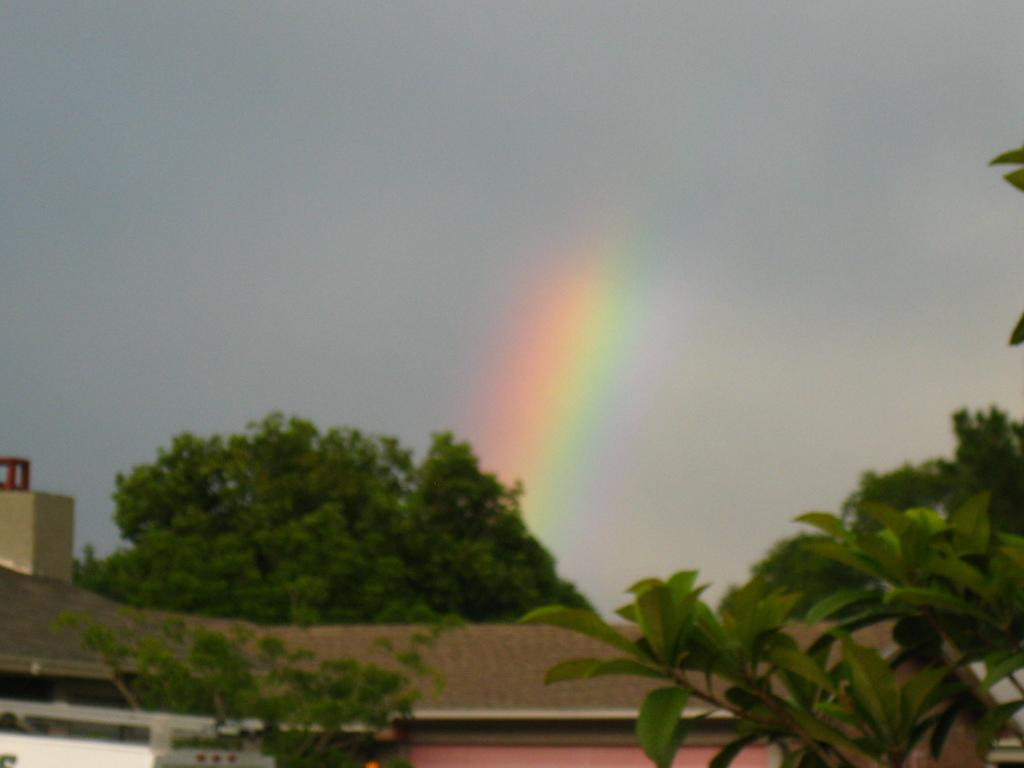What type of vegetation can be seen in the image? There are trees in the image. What type of structure is visible in the image? There is a house in the image. What is visible in the background of the image? The sky is visible in the image. How many hens are perched on the blade in the image? There are no hens or blades present in the image. 